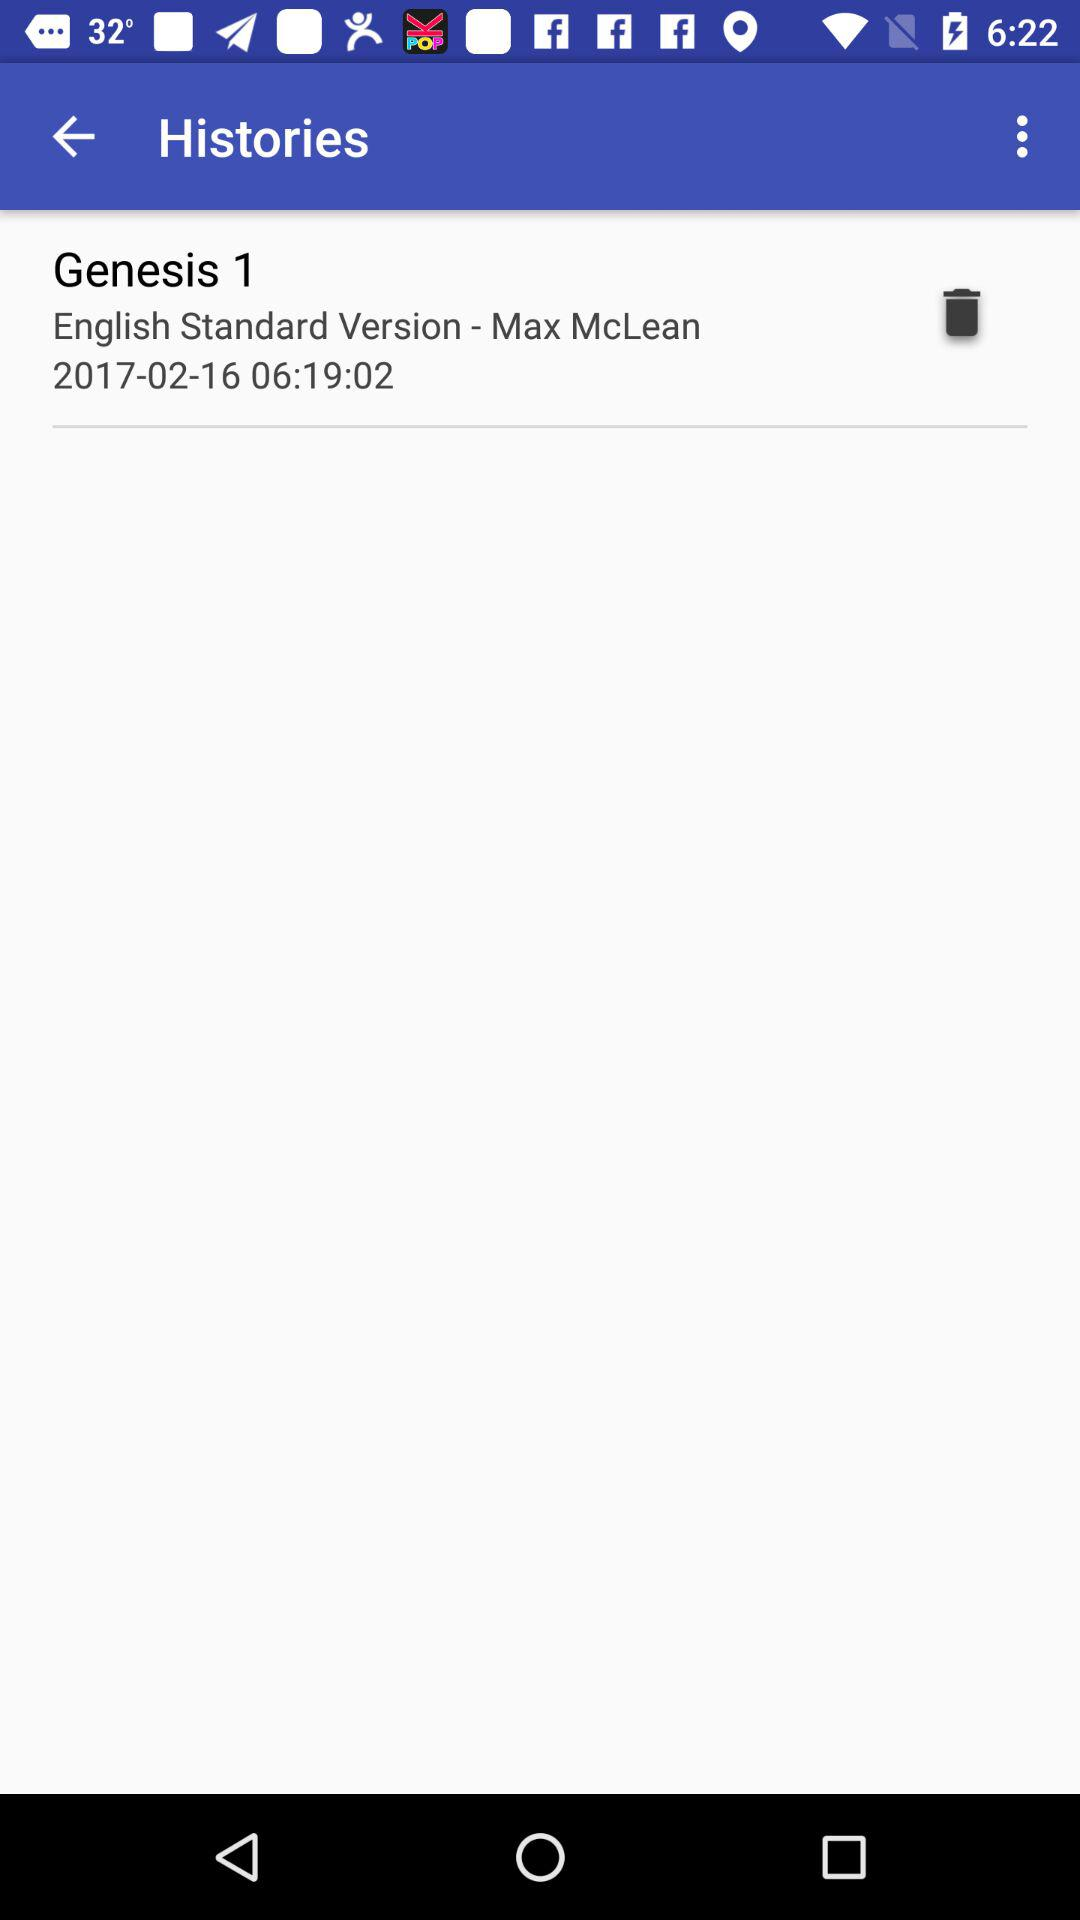What is the shown time duration? The shown time duration is 6 hours 19 minutes 2 seconds. 